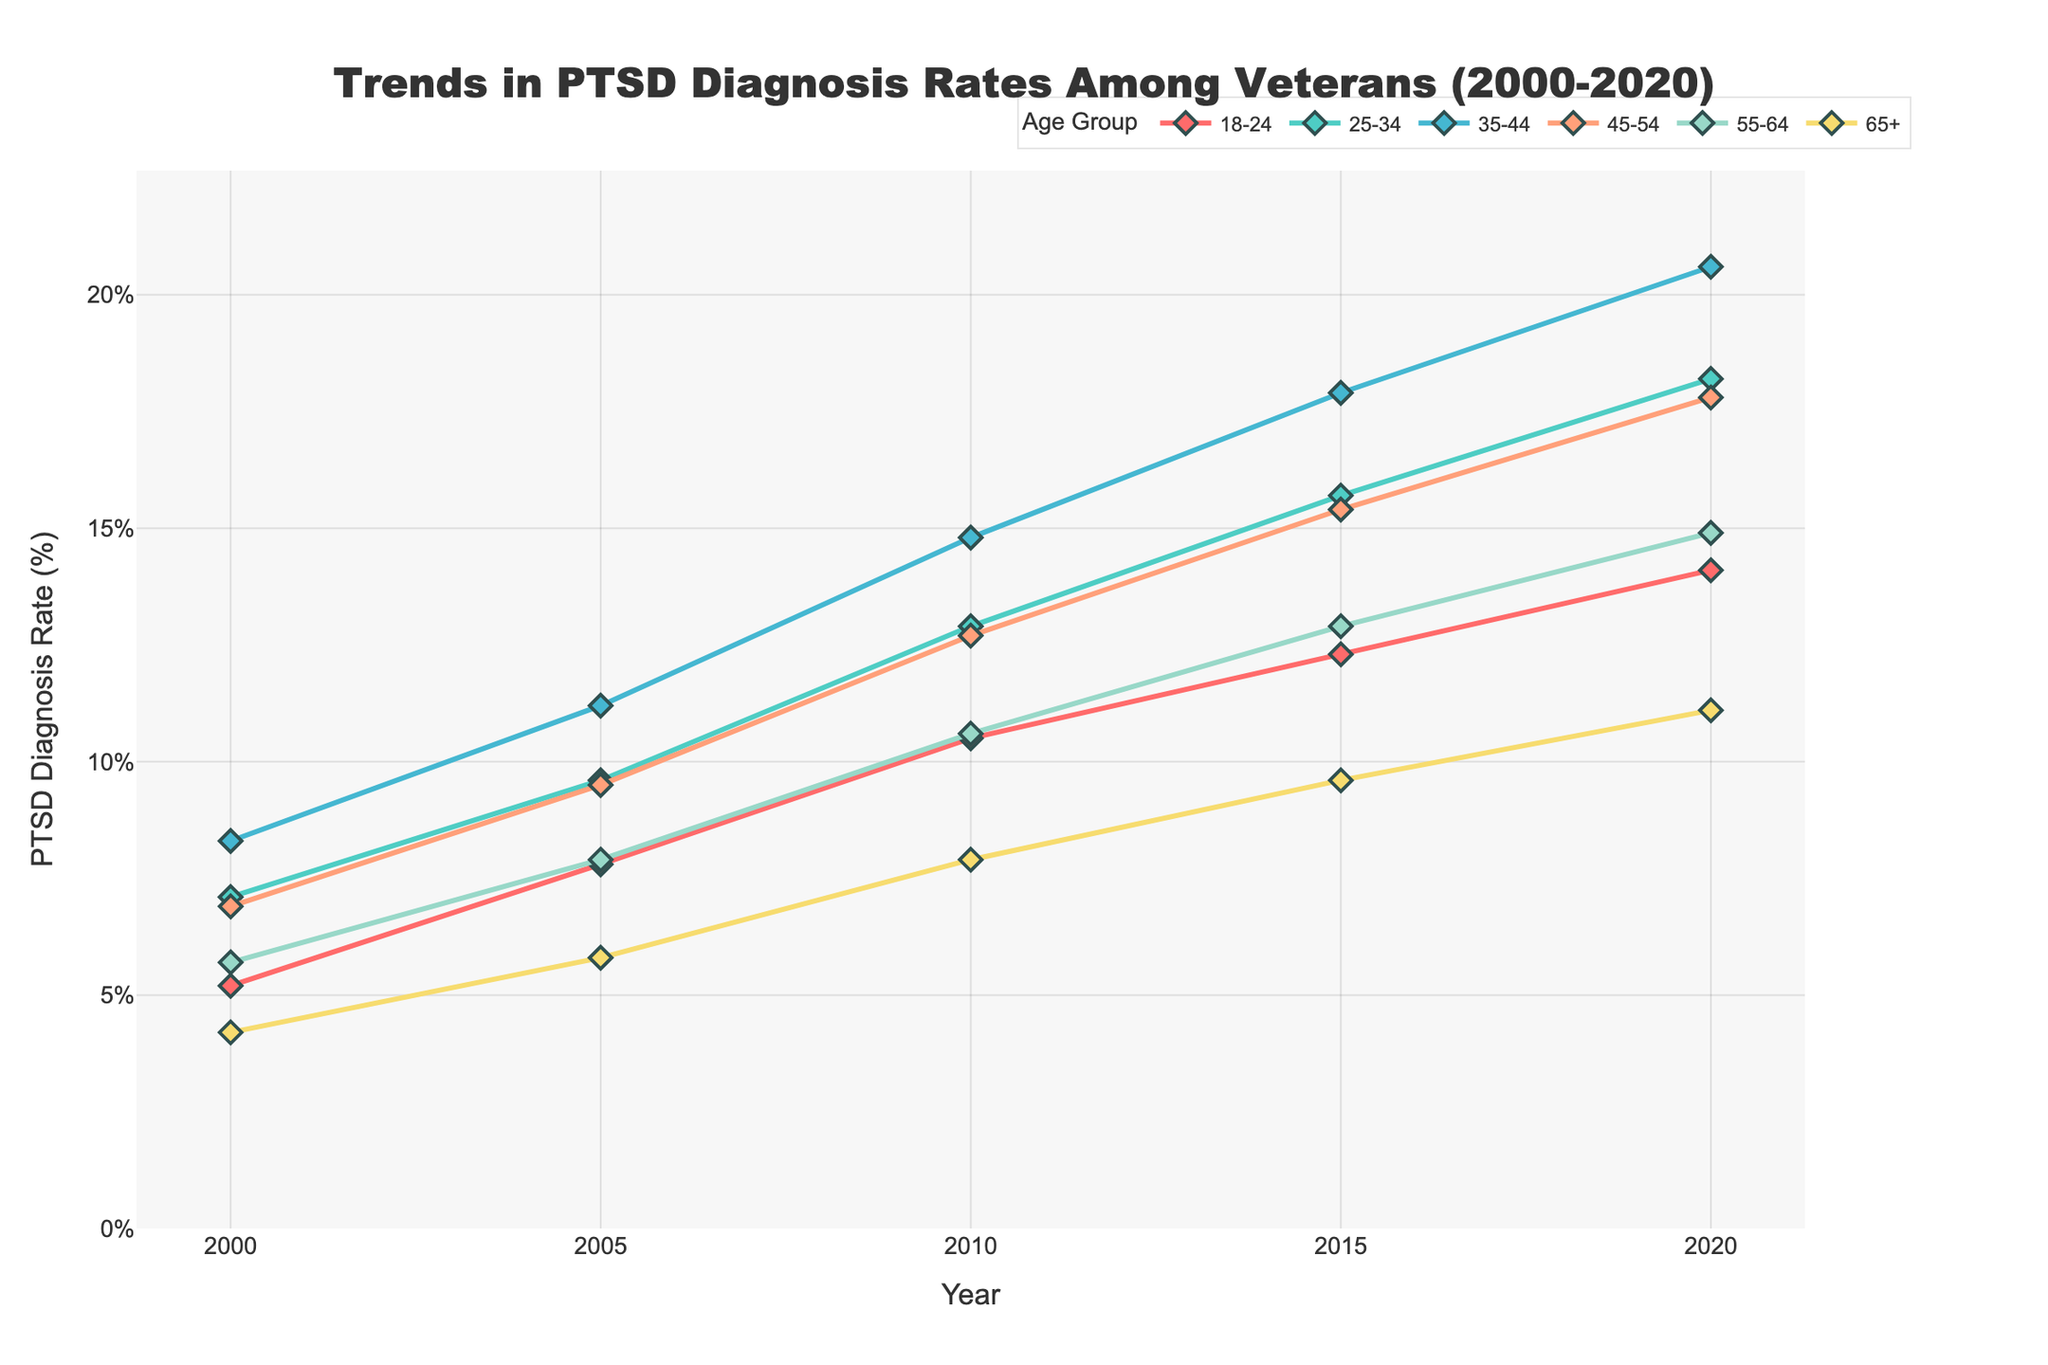What's the trend in PTSD diagnosis rates for the 18-24 age group over the past two decades? To find the trend in PTSD diagnosis rates for the 18-24 age group, we look at the plotted line for this group in the graph. The points for 2000, 2005, 2010, 2015, and 2020 should indicate an increasing pattern.
Answer: Increasing Which age group had the highest PTSD diagnosis rate in 2020? From the graph, we compare the ends of all the lines in 2020. The 35-44 age group has the highest final data point.
Answer: 35-44 How did the PTSD diagnosis rate for the 65+ age group change from 2000 to 2020? To find the change in the PTSD diagnosis rate for the 65+ age group, we look at the start and end points of the line for this group. The diagnosis rate increased from 4.2% in 2000 to 11.1% in 2020.
Answer: Increased What is the difference in PTSD diagnosis rates between the 25-34 and 45-54 age groups in 2010? We find the points for both age groups in the year 2010 from the graph. The diagnosis rates are 12.9% for 25-34 and 12.7% for 45-54. The difference is calculated as 12.9% - 12.7%.
Answer: 0.2% Which age group saw the biggest increase in PTSD diagnosis rates between 2000 and 2020? By comparing the start and end points of each age group on the chart, we calculate the increase for each. The 35-44 age group increased by 20.6% - 8.3%, which is the largest increase of 12.3 percentage points.
Answer: 35-44 What was the average PTSD diagnosis rate for the 25-34 age group over the two decades? To find the average, sum the PTSD diagnosis rates for the 25-34 age group at each time (7.1, 9.6, 12.9, 15.7, 18.2), then divide by the number of data points (5). Thus, (7.1 + 9.6 + 12.9 + 15.7 + 18.2) / 5 = 12.7.
Answer: 12.7% Between which consecutive years did the 55-64 age group experience the highest rate of increase? To find this, we compare the rate of increase between each consecutive pair of years (2000-2005, 2005-2010, 2010-2015, 2015-2020) for the 55-64 age group. The highest increase is found from 2010 to 2015, which is 12.9% - 10.6% = 2.3 percentage points.
Answer: 2010-2015 Which age group lines appear closest together in the year 2000? We compare the beginning points for each age group in 2000 and check which two have the smallest difference. The 25-34 and 45-54 age groups are closest with rates of 7.1% and 6.9%, respectively.
Answer: 25-34 and 45-54 What is the median PTSD diagnosis rate for all age groups in 2015? To find the median, list the PTSD diagnosis rates for all age groups in 2015 (12.3, 15.7, 17.9, 15.4, 12.9, 9.6) and arrange them in ascending order: 9.6, 12.3, 12.9, 15.4, 15.7, 17.9. The median is the average of the two middle values (12.9 and 15.4).
Answer: 14.15% 